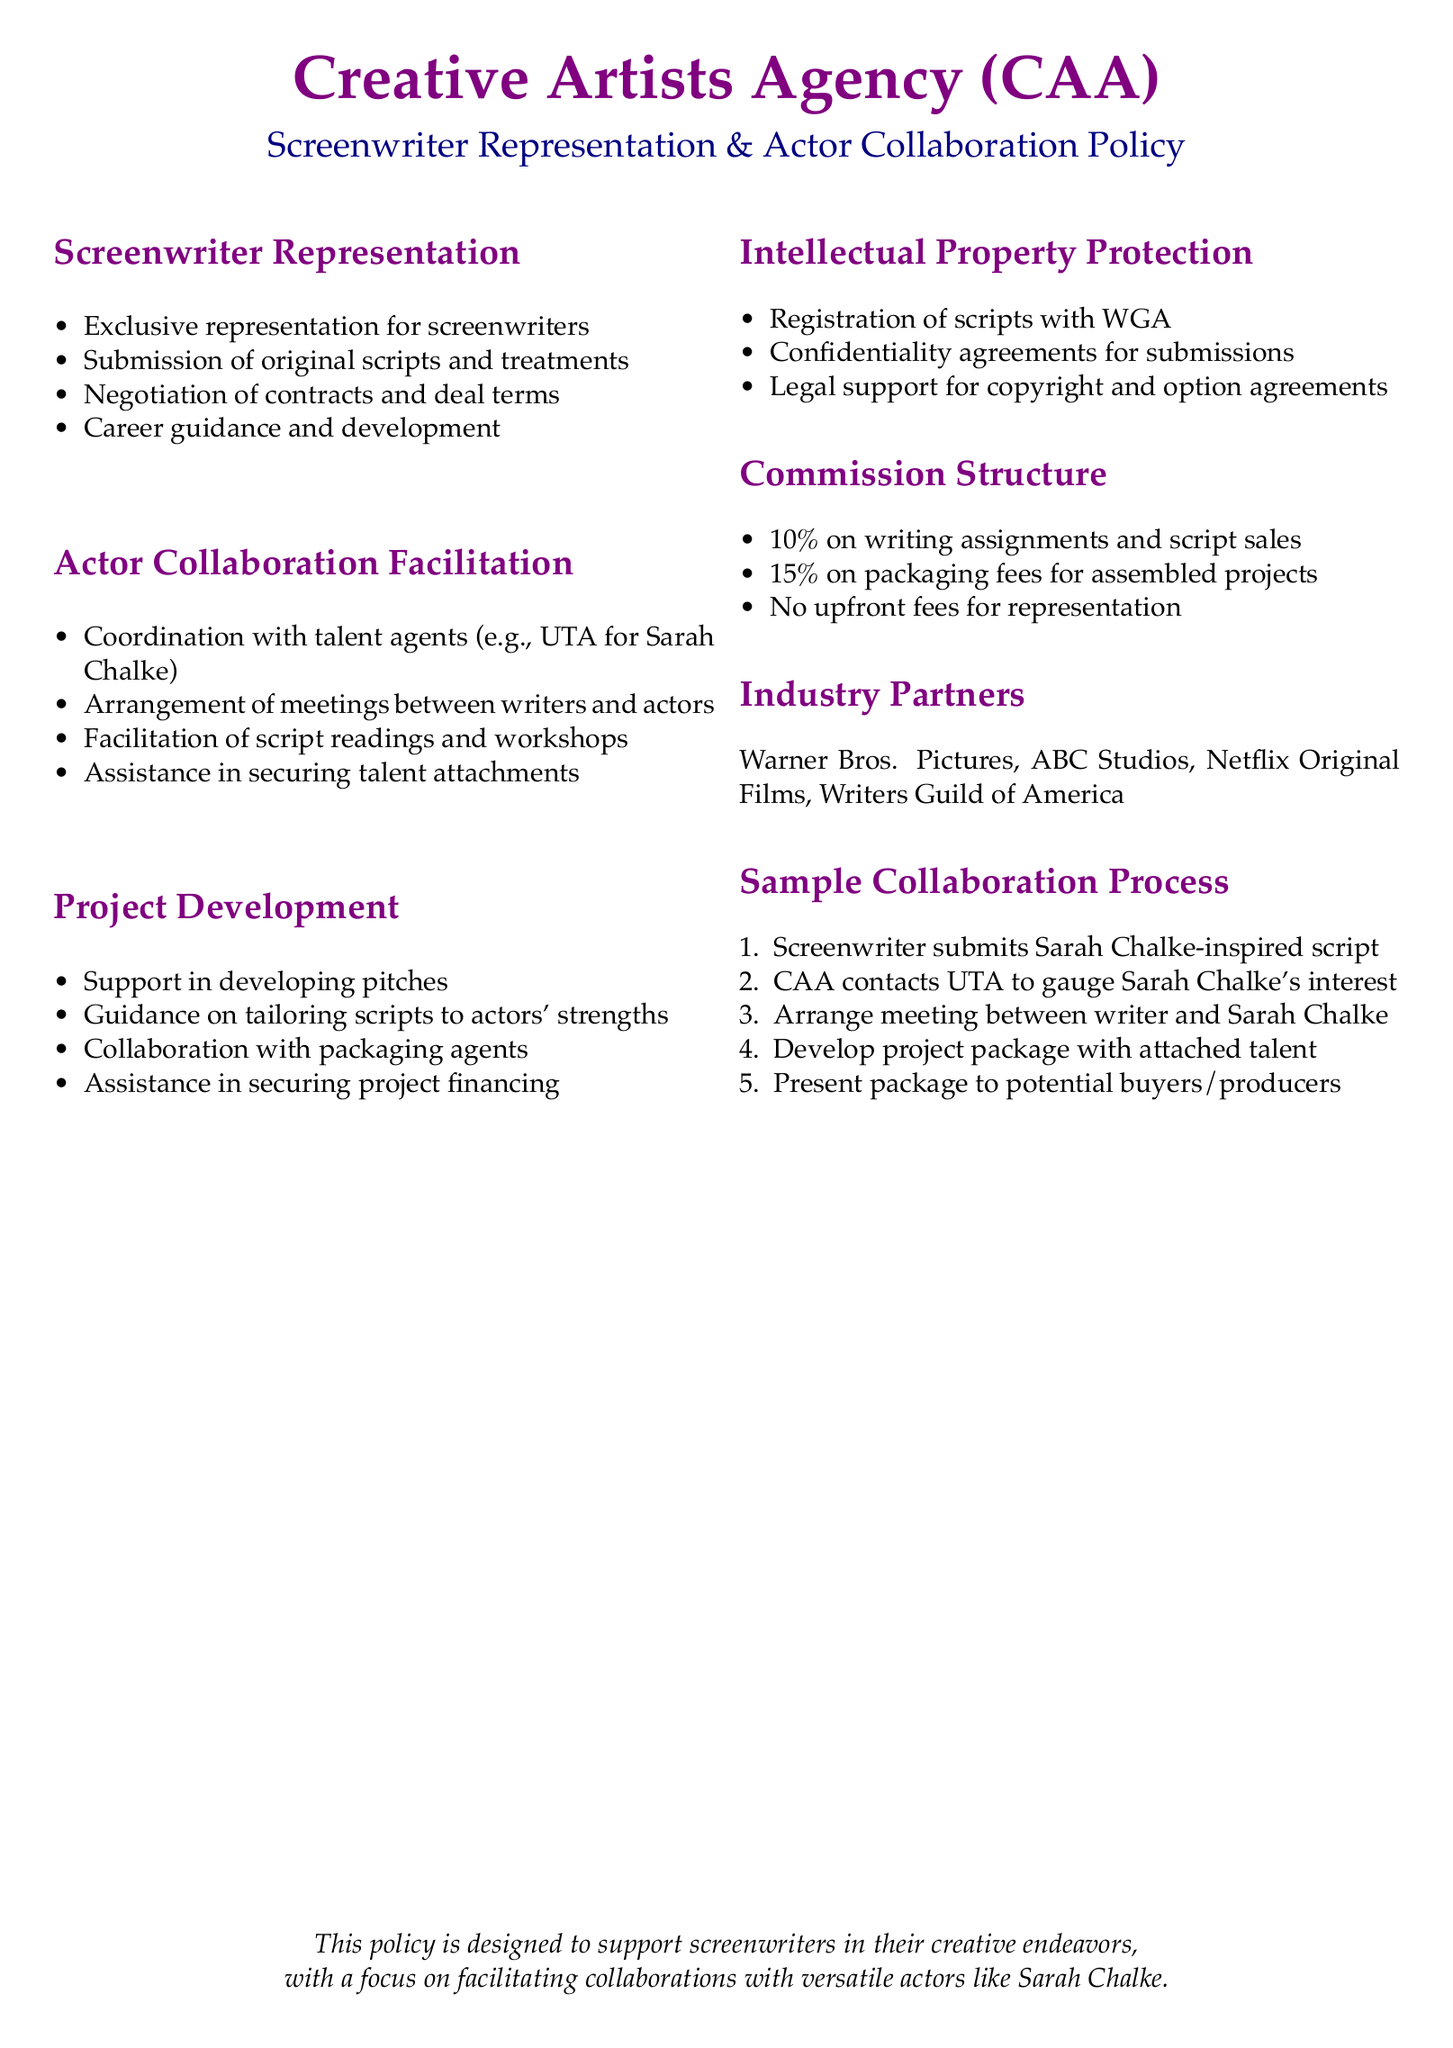What is the commission percentage for writing assignments? The commission percentage for writing assignments is stated in the document under the Commission Structure.
Answer: 10% Who does CAA coordinate with for talent collaboration? The document specifies that CAA coordinates with talent agents, mentioning UTA as an example.
Answer: UTA What types of support do they offer in project development? The document outlines support areas in project development under the respective section, including guidance and assistance.
Answer: Developing pitches What is the purpose of the confidentiality agreements mentioned? The document explains confidentiality agreements are for submissions under Intellectual Property Protection.
Answer: Submissions In what step does the screenwriter submit their script? The sample collaboration process outlines that the screenwriter submits the script as the first step in the collaboration process.
Answer: First step What is the role of the Writers Guild of America mentioned in the document? The document lists the Writers Guild of America as an industry partner, which implies a supportive role in representation.
Answer: Industry partner What percentage is charged on packaging fees for assembled projects? The document explicitly states the commission percentage charged on packaging fees.
Answer: 15% What does career guidance for screenwriters include according to the document? The document describes career guidance as one of the services included under screenwriter representation.
Answer: Career development 